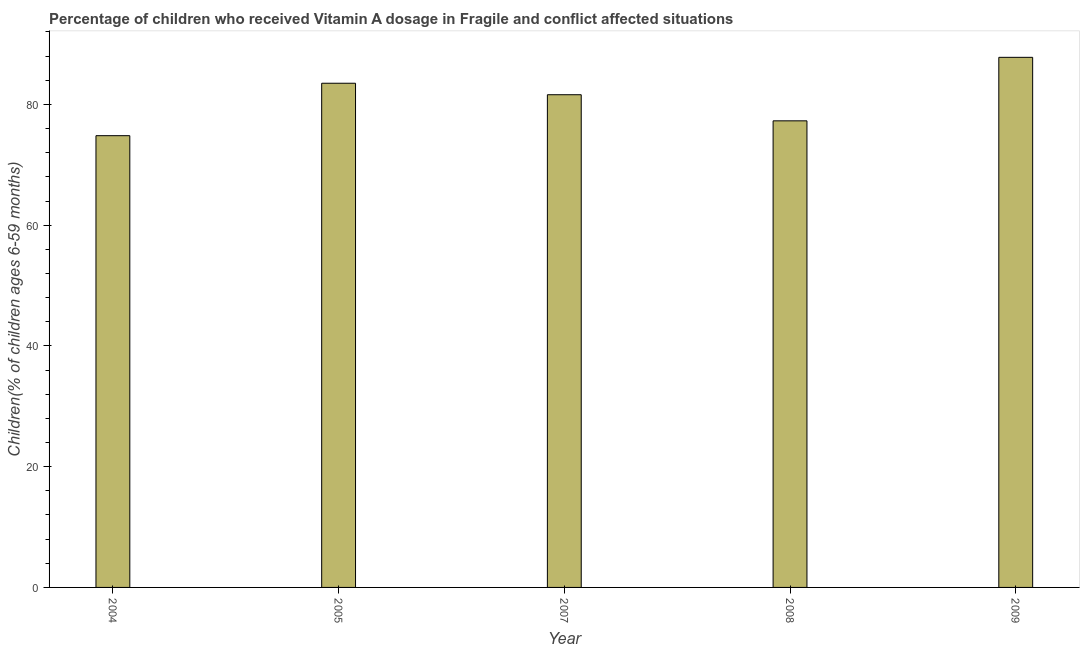Does the graph contain any zero values?
Your response must be concise. No. Does the graph contain grids?
Offer a terse response. No. What is the title of the graph?
Ensure brevity in your answer.  Percentage of children who received Vitamin A dosage in Fragile and conflict affected situations. What is the label or title of the X-axis?
Keep it short and to the point. Year. What is the label or title of the Y-axis?
Keep it short and to the point. Children(% of children ages 6-59 months). What is the vitamin a supplementation coverage rate in 2007?
Offer a very short reply. 81.61. Across all years, what is the maximum vitamin a supplementation coverage rate?
Provide a succinct answer. 87.8. Across all years, what is the minimum vitamin a supplementation coverage rate?
Offer a terse response. 74.83. In which year was the vitamin a supplementation coverage rate minimum?
Make the answer very short. 2004. What is the sum of the vitamin a supplementation coverage rate?
Make the answer very short. 405.03. What is the difference between the vitamin a supplementation coverage rate in 2005 and 2008?
Your answer should be compact. 6.23. What is the average vitamin a supplementation coverage rate per year?
Keep it short and to the point. 81.01. What is the median vitamin a supplementation coverage rate?
Ensure brevity in your answer.  81.61. What is the ratio of the vitamin a supplementation coverage rate in 2004 to that in 2005?
Your response must be concise. 0.9. Is the difference between the vitamin a supplementation coverage rate in 2005 and 2009 greater than the difference between any two years?
Give a very brief answer. No. What is the difference between the highest and the second highest vitamin a supplementation coverage rate?
Offer a very short reply. 4.29. What is the difference between the highest and the lowest vitamin a supplementation coverage rate?
Provide a succinct answer. 12.98. Are all the bars in the graph horizontal?
Your answer should be very brief. No. How many years are there in the graph?
Your answer should be compact. 5. What is the difference between two consecutive major ticks on the Y-axis?
Your answer should be very brief. 20. What is the Children(% of children ages 6-59 months) of 2004?
Make the answer very short. 74.83. What is the Children(% of children ages 6-59 months) of 2005?
Ensure brevity in your answer.  83.51. What is the Children(% of children ages 6-59 months) in 2007?
Provide a succinct answer. 81.61. What is the Children(% of children ages 6-59 months) of 2008?
Provide a succinct answer. 77.28. What is the Children(% of children ages 6-59 months) of 2009?
Your response must be concise. 87.8. What is the difference between the Children(% of children ages 6-59 months) in 2004 and 2005?
Your answer should be very brief. -8.69. What is the difference between the Children(% of children ages 6-59 months) in 2004 and 2007?
Provide a short and direct response. -6.78. What is the difference between the Children(% of children ages 6-59 months) in 2004 and 2008?
Keep it short and to the point. -2.46. What is the difference between the Children(% of children ages 6-59 months) in 2004 and 2009?
Offer a terse response. -12.98. What is the difference between the Children(% of children ages 6-59 months) in 2005 and 2007?
Offer a very short reply. 1.9. What is the difference between the Children(% of children ages 6-59 months) in 2005 and 2008?
Provide a short and direct response. 6.23. What is the difference between the Children(% of children ages 6-59 months) in 2005 and 2009?
Offer a terse response. -4.29. What is the difference between the Children(% of children ages 6-59 months) in 2007 and 2008?
Provide a succinct answer. 4.33. What is the difference between the Children(% of children ages 6-59 months) in 2007 and 2009?
Provide a succinct answer. -6.19. What is the difference between the Children(% of children ages 6-59 months) in 2008 and 2009?
Keep it short and to the point. -10.52. What is the ratio of the Children(% of children ages 6-59 months) in 2004 to that in 2005?
Offer a very short reply. 0.9. What is the ratio of the Children(% of children ages 6-59 months) in 2004 to that in 2007?
Give a very brief answer. 0.92. What is the ratio of the Children(% of children ages 6-59 months) in 2004 to that in 2009?
Give a very brief answer. 0.85. What is the ratio of the Children(% of children ages 6-59 months) in 2005 to that in 2007?
Your answer should be compact. 1.02. What is the ratio of the Children(% of children ages 6-59 months) in 2005 to that in 2008?
Ensure brevity in your answer.  1.08. What is the ratio of the Children(% of children ages 6-59 months) in 2005 to that in 2009?
Your answer should be compact. 0.95. What is the ratio of the Children(% of children ages 6-59 months) in 2007 to that in 2008?
Your response must be concise. 1.06. What is the ratio of the Children(% of children ages 6-59 months) in 2007 to that in 2009?
Provide a succinct answer. 0.93. 